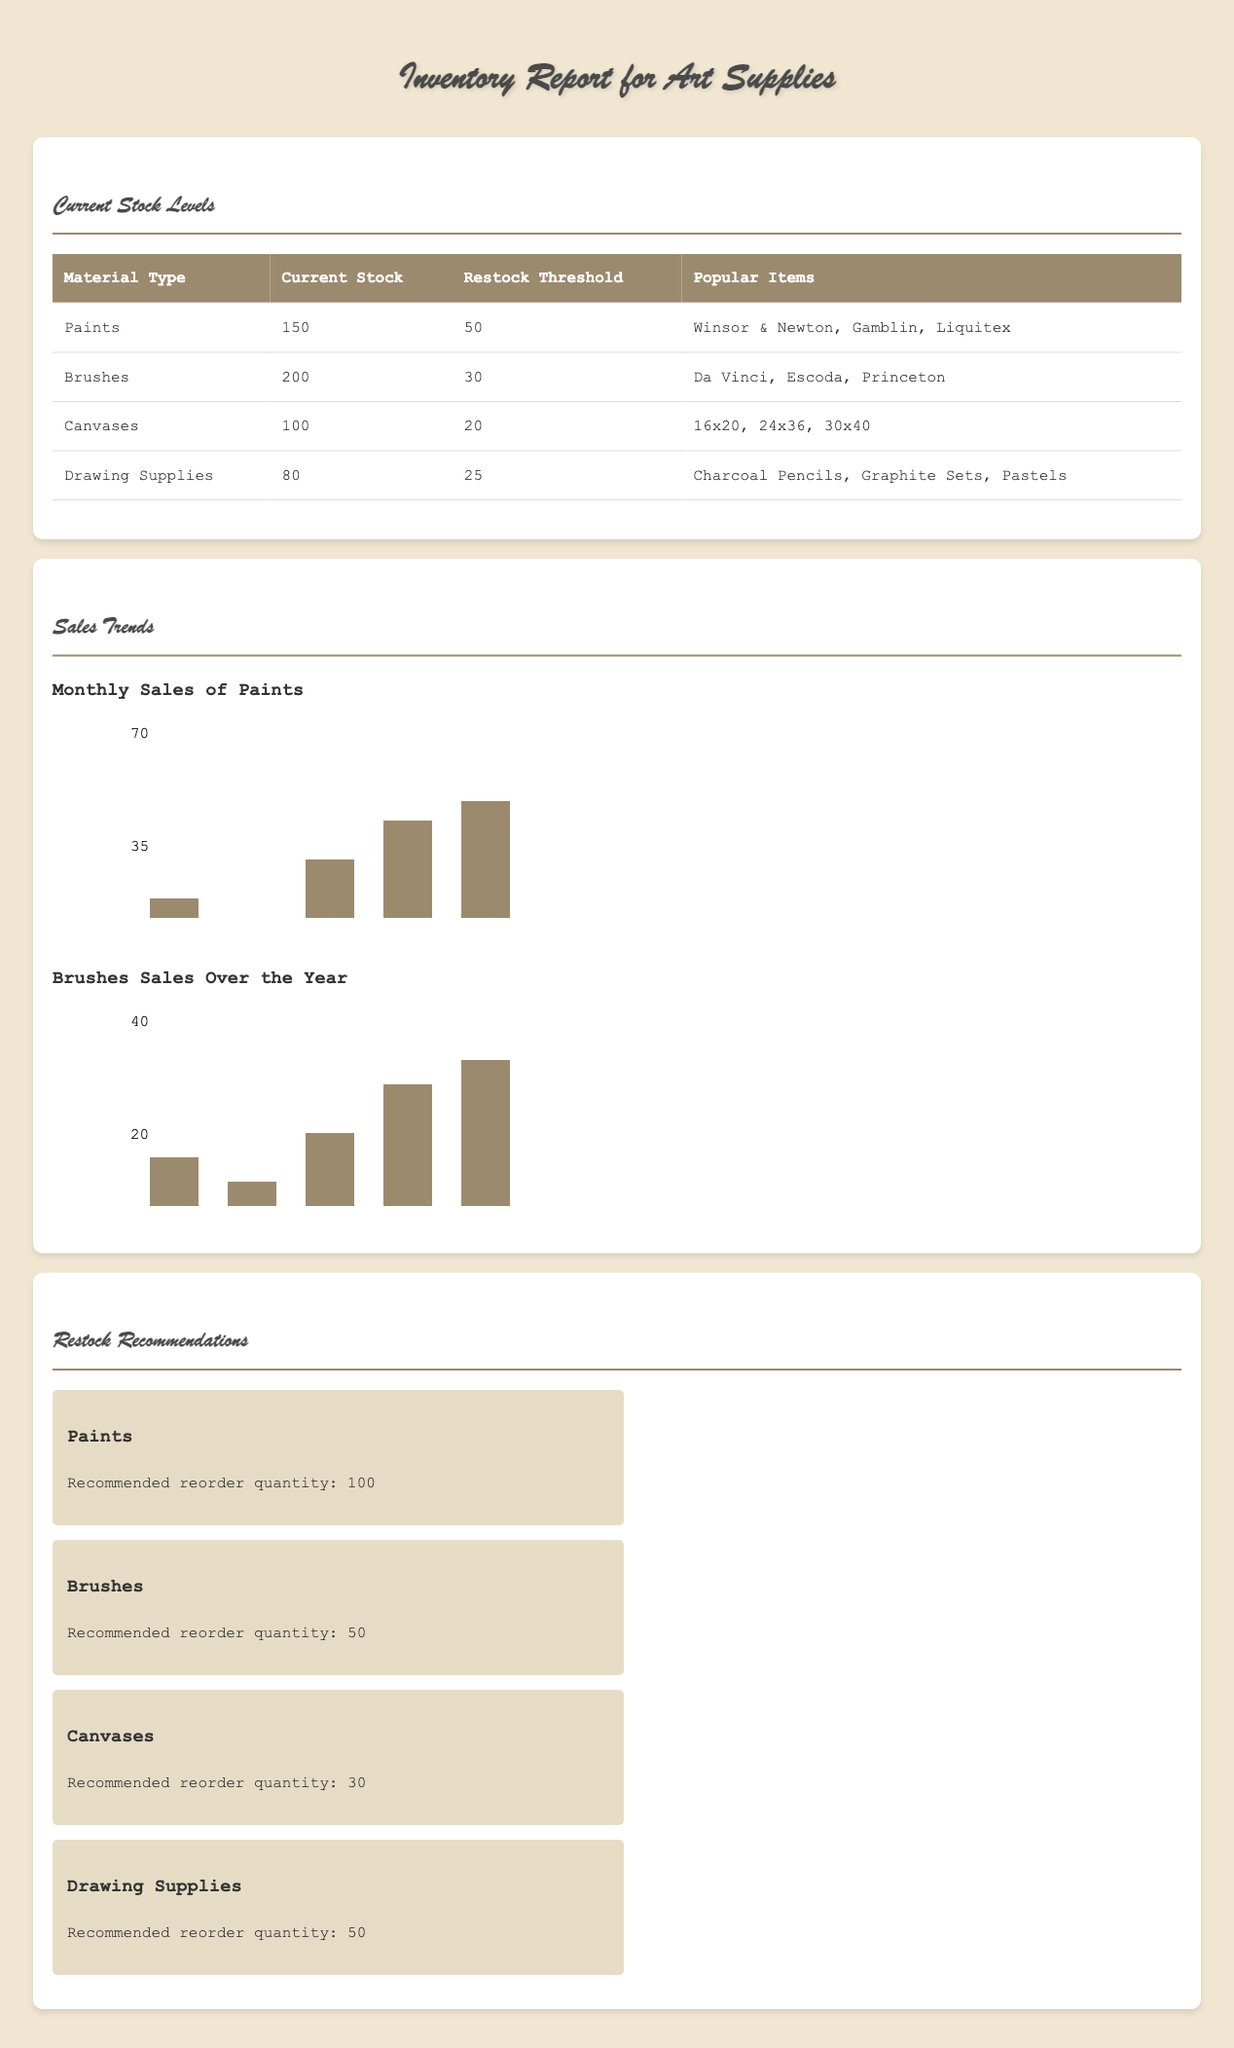What is the current stock level of paints? The current stock level of paints is clearly stated in the document, which shows 150 units.
Answer: 150 What is the restock threshold for brushes? The document specifies that the restock threshold for brushes is 30 units.
Answer: 30 Which brand of paints is listed as popular? The document provides examples of popular paint brands, one of which is Winsor & Newton.
Answer: Winsor & Newton How many recommended reorder units for canvases? The section on restock recommendations indicates the suggested reorder quantity for canvases is 30 units.
Answer: 30 What trend is shown for monthly sales of paints? The visual graph provided depicts monthly sales of paints and emphasizes the sales trends throughout the months.
Answer: Sales trends What is the current stock of drawing supplies? The document indicates that the current stock of drawing supplies is 80 units.
Answer: 80 Which material type has the highest current stock? By reviewing the current stock levels, it can be inferred that brushes have the highest stock at 200 units.
Answer: Brushes How many months of data are represented in the sales trends? The displayed sales trends cover a six-month period, from January to June.
Answer: Six months What is the recommended reorder quantity for brushes? According to the restock recommendations section, the suggested reorder quantity for brushes is 50 units.
Answer: 50 